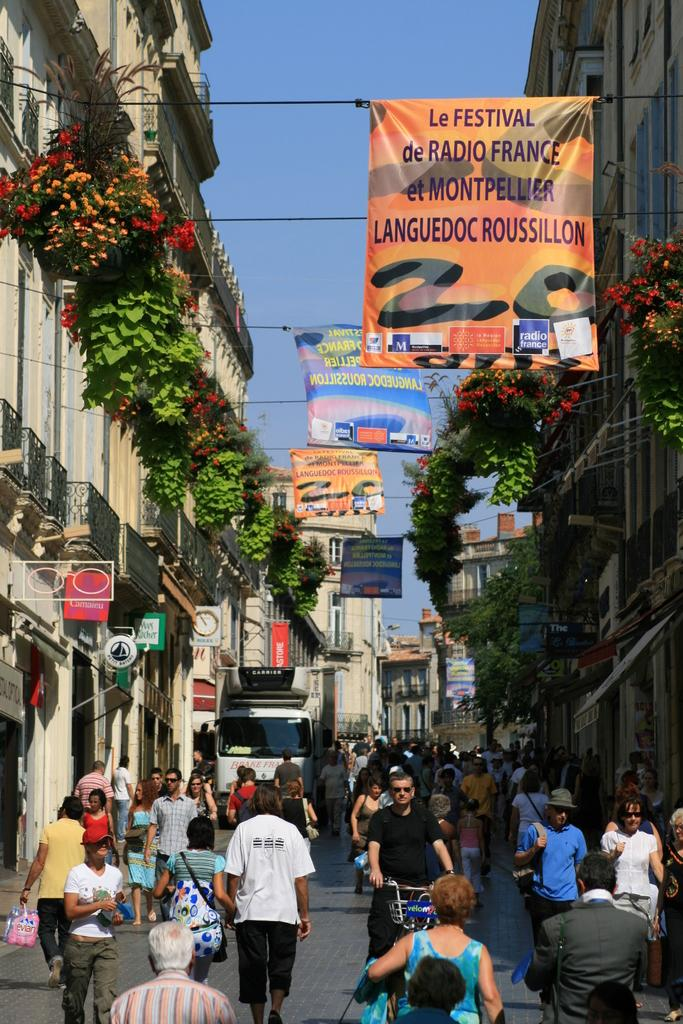How many people are in the group visible in the image? There is a group of people in the image, but the exact number is not specified. What type of vehicle is in the image? There is a vehicle in the image, but its specific type is not mentioned. What mode of transportation is also present in the image? There is a bicycle in the image. What can be seen in the background of the image? In the background of the image, there are buildings, banners, plants with flowers, the sky, and some unspecified objects. What type of silk is being used to make the authority's position more comfortable in the image? There is no mention of silk, authority, or position in the image. 